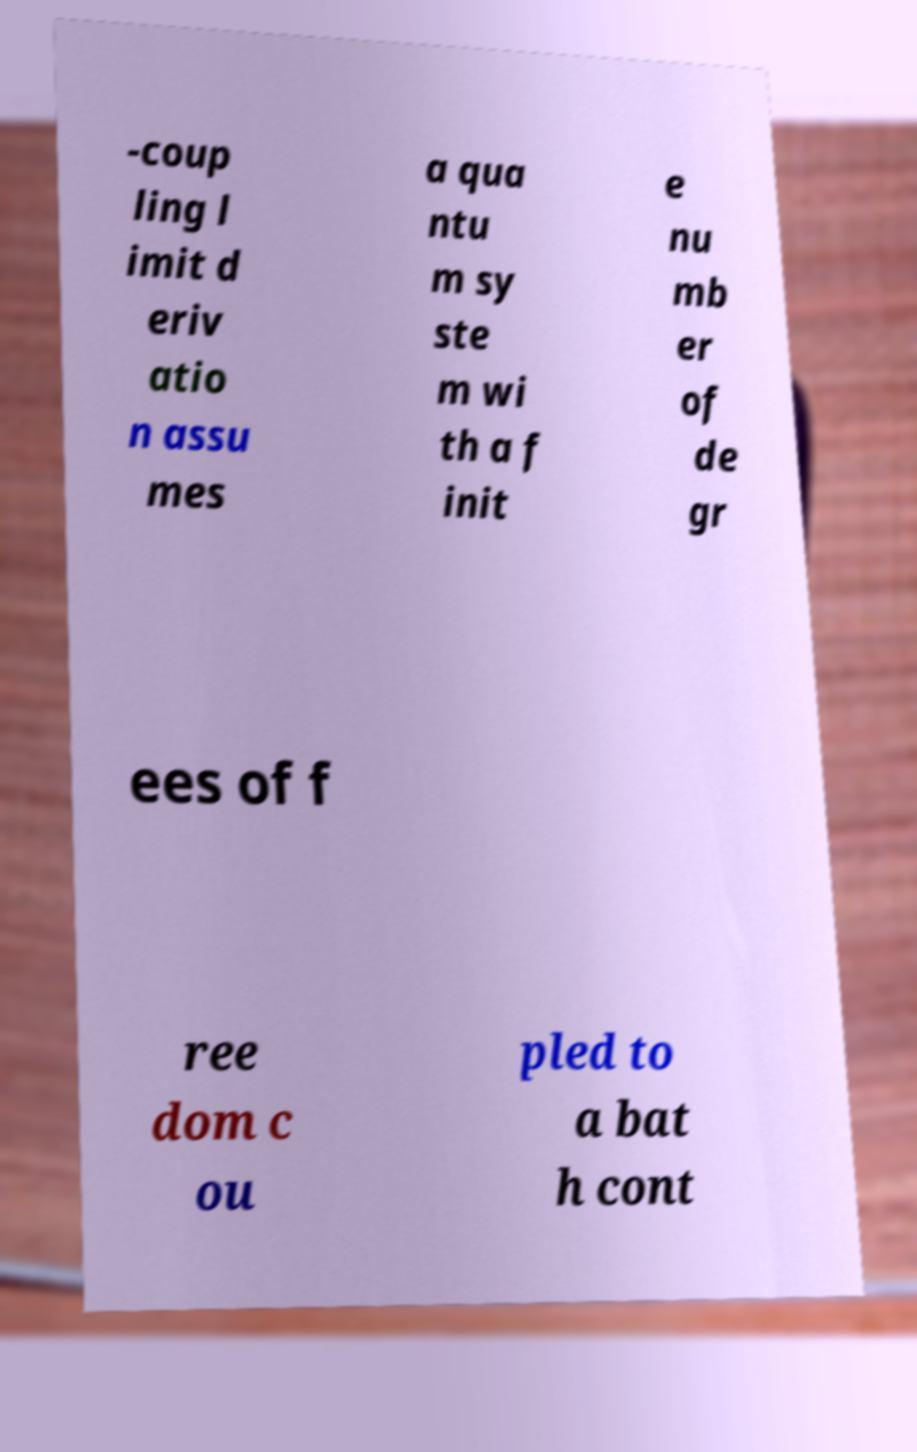Could you extract and type out the text from this image? -coup ling l imit d eriv atio n assu mes a qua ntu m sy ste m wi th a f init e nu mb er of de gr ees of f ree dom c ou pled to a bat h cont 